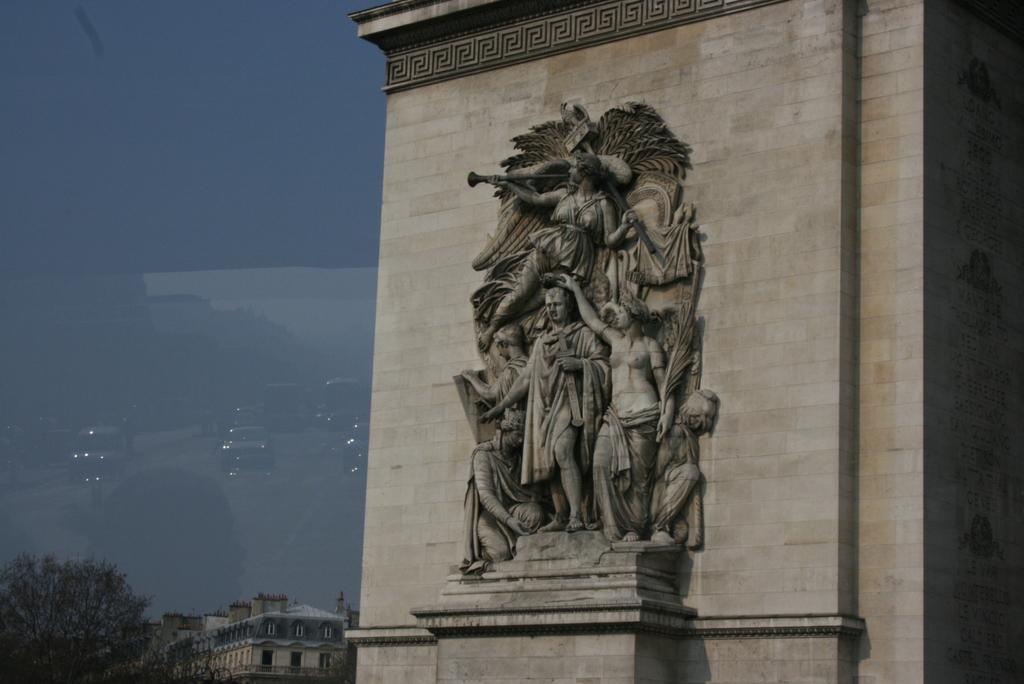In one or two sentences, can you explain what this image depicts? In this image I can see there are buildings and a statue. On the side there is a reflection of the cars. There are trees. 